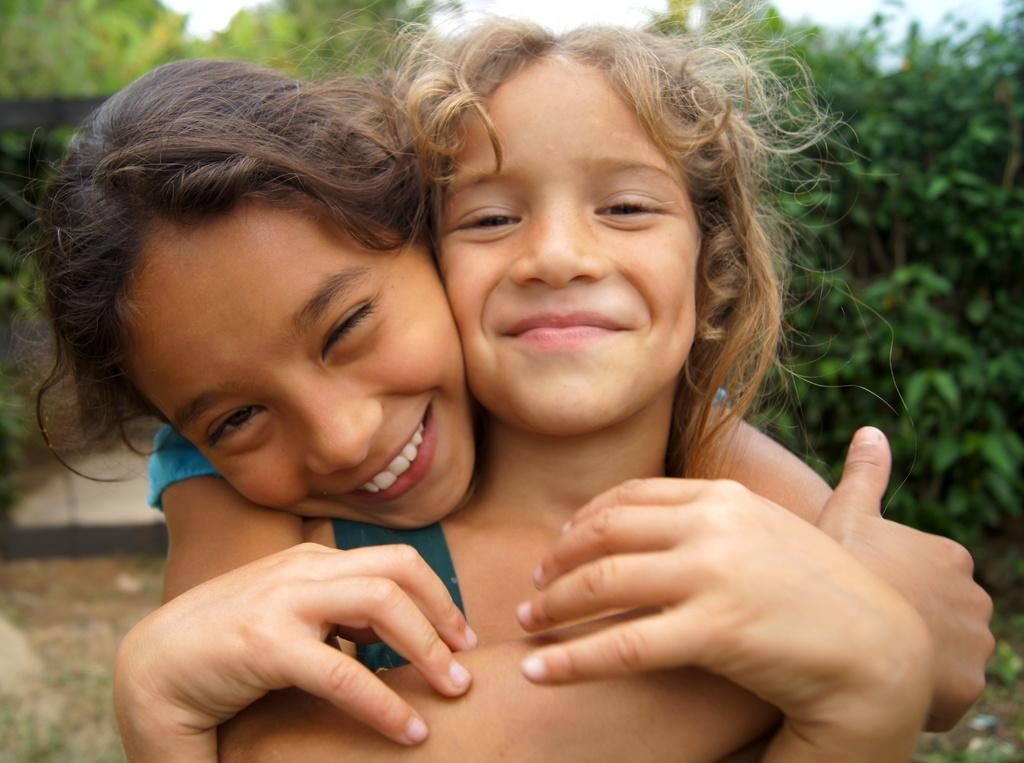How many people are in the image? There are two girls in the image. What can be seen in the background of the image? There are trees in the background of the image. How many legs does the fact have in the image? There is no fact present in the image, and therefore no legs can be attributed to it. 